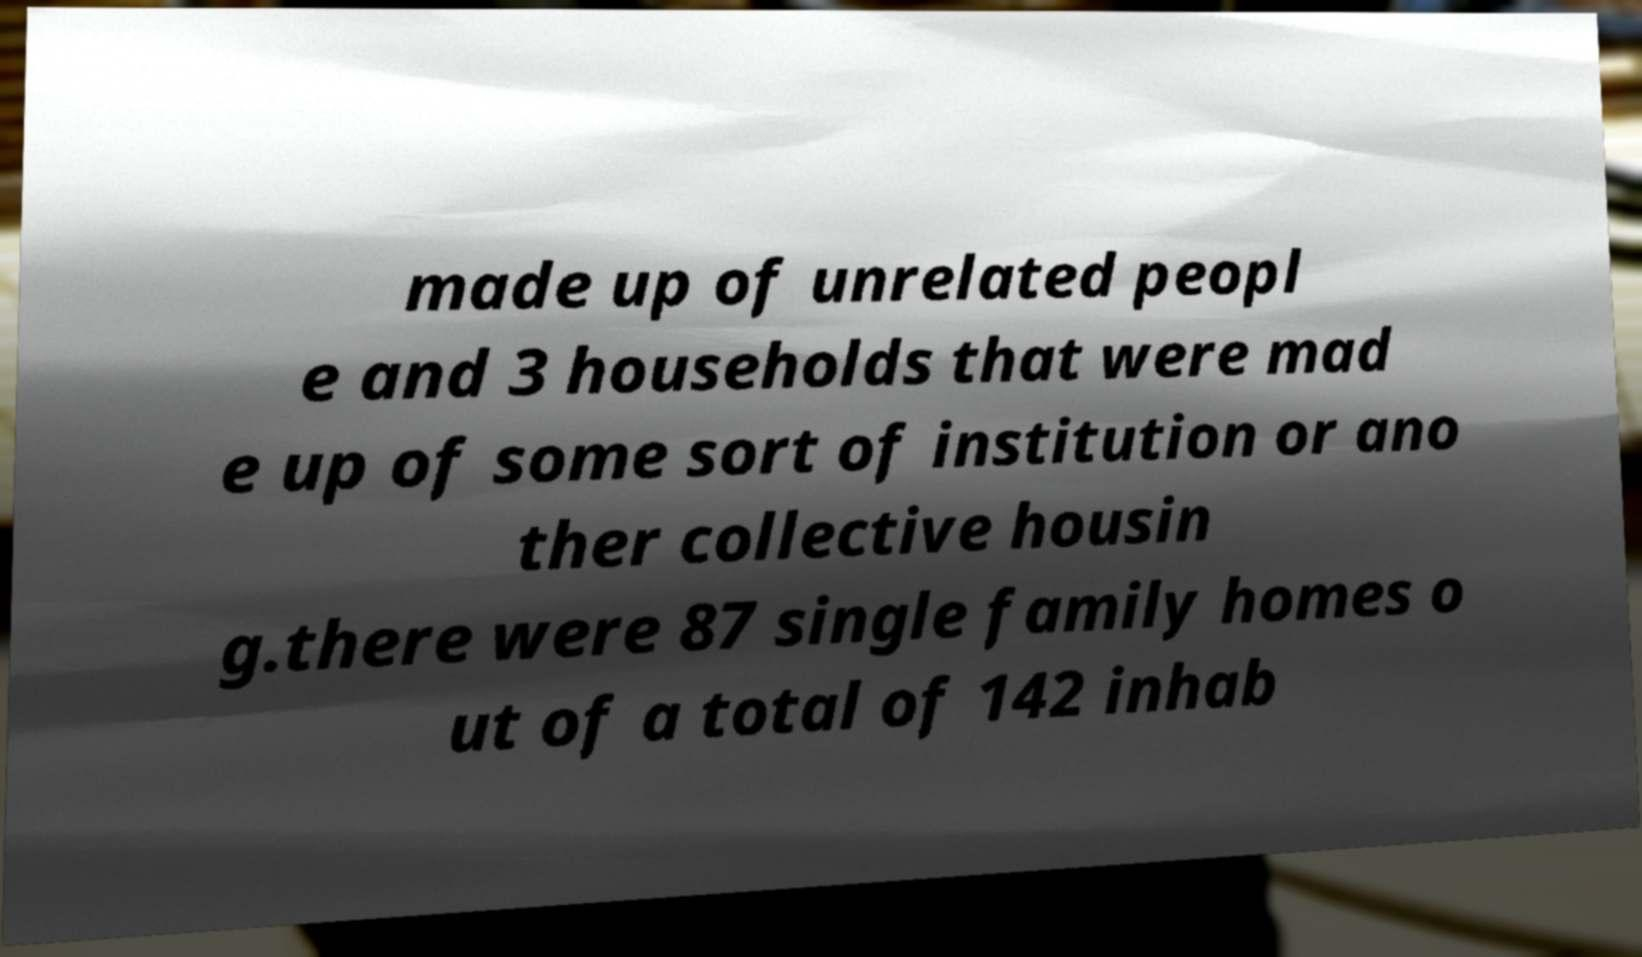Can you read and provide the text displayed in the image?This photo seems to have some interesting text. Can you extract and type it out for me? made up of unrelated peopl e and 3 households that were mad e up of some sort of institution or ano ther collective housin g.there were 87 single family homes o ut of a total of 142 inhab 